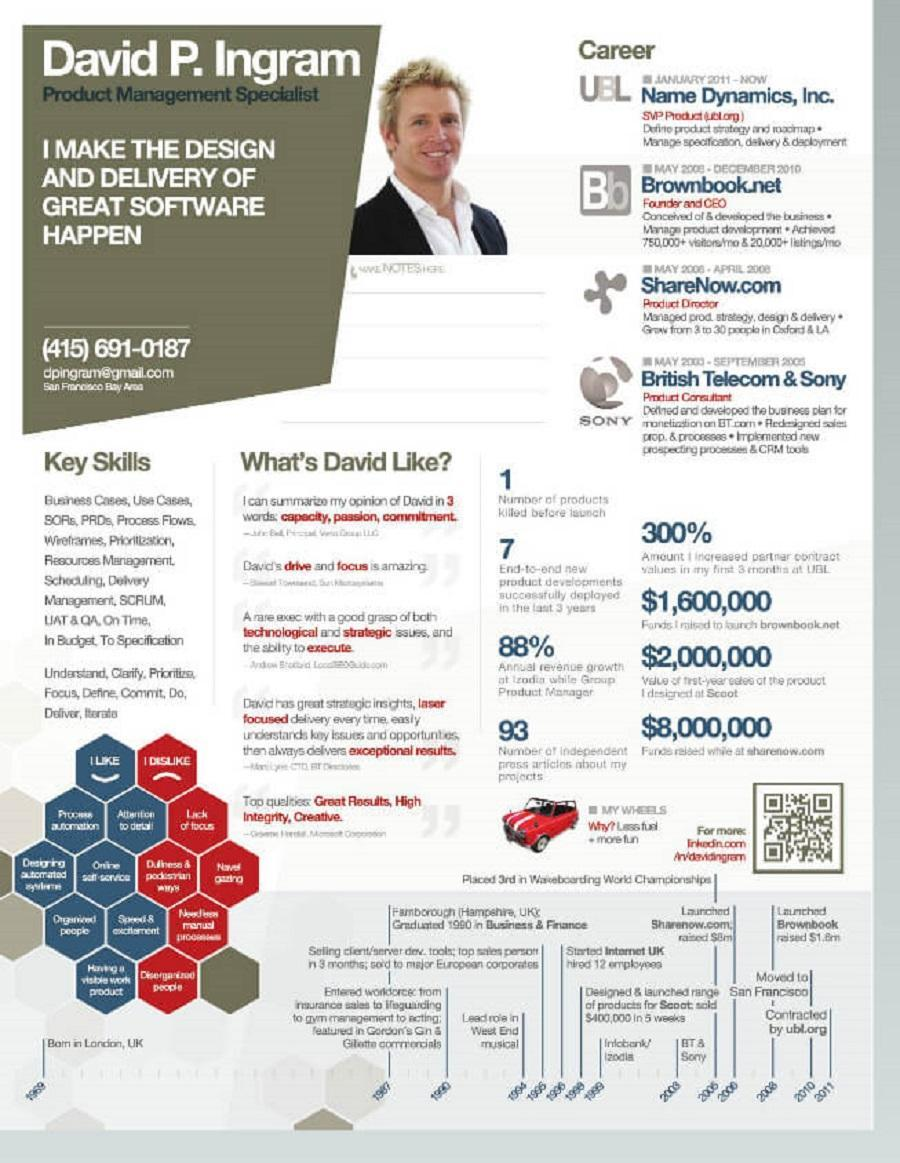How many Likes of David are listed?
Answer the question with a short phrase. 7 How many dislikes are there for David? 5 What is the name of the second company of David? ShareNow.com What is the name of the first company of David? SONY 